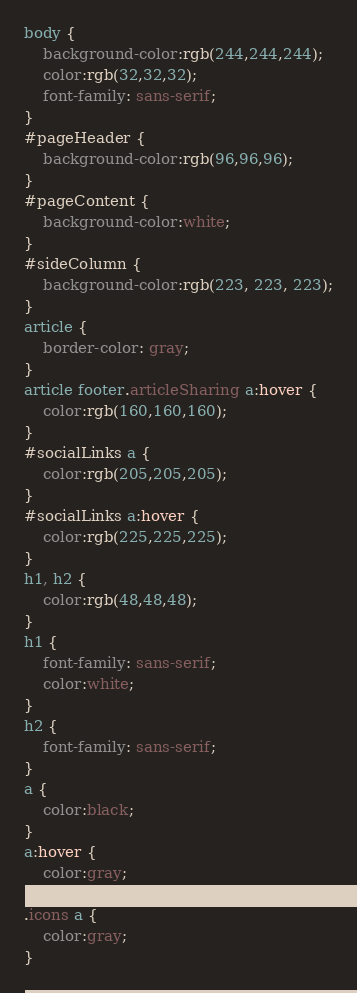<code> <loc_0><loc_0><loc_500><loc_500><_CSS_>body {
	background-color:rgb(244,244,244);
	color:rgb(32,32,32);
	font-family: sans-serif;
}
#pageHeader {
	background-color:rgb(96,96,96);
}
#pageContent {
	background-color:white;
}
#sideColumn {
	background-color:rgb(223, 223, 223);
}
article {
	border-color: gray;
}
article footer.articleSharing a:hover {
	color:rgb(160,160,160);
}
#socialLinks a {
	color:rgb(205,205,205);
}
#socialLinks a:hover {
	color:rgb(225,225,225);
}
h1, h2 {
	color:rgb(48,48,48);
}
h1 {
	font-family: sans-serif;
	color:white;
}
h2 {
	font-family: sans-serif;
}
a {
	color:black;
}
a:hover {
	color:gray;
}
.icons a {
	color:gray;
}
</code> 